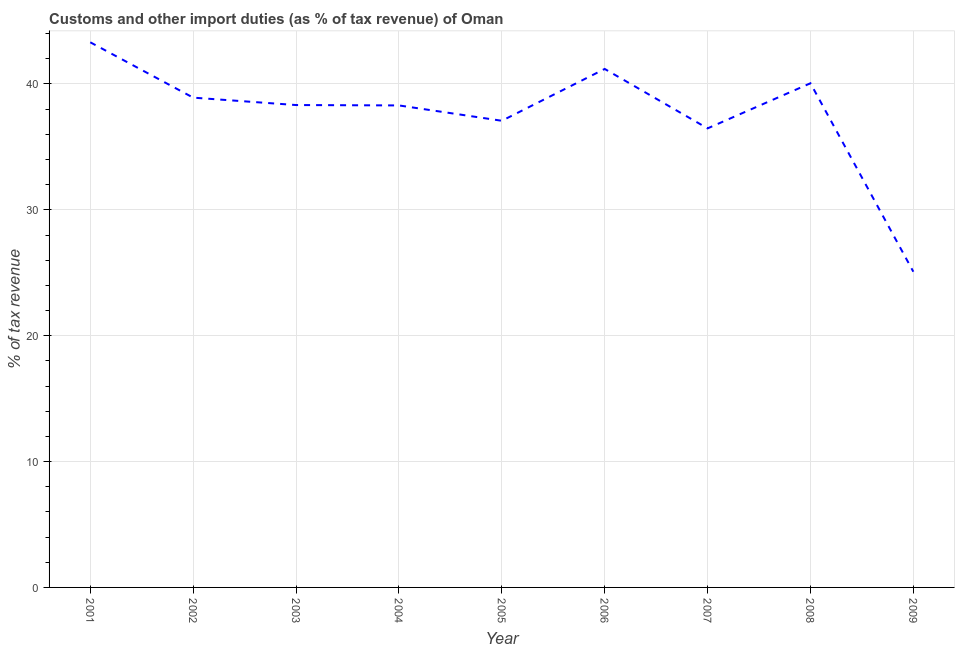What is the customs and other import duties in 2009?
Your response must be concise. 25.08. Across all years, what is the maximum customs and other import duties?
Provide a short and direct response. 43.31. Across all years, what is the minimum customs and other import duties?
Provide a short and direct response. 25.08. What is the sum of the customs and other import duties?
Keep it short and to the point. 338.73. What is the difference between the customs and other import duties in 2001 and 2003?
Provide a succinct answer. 4.99. What is the average customs and other import duties per year?
Your answer should be very brief. 37.64. What is the median customs and other import duties?
Provide a short and direct response. 38.33. In how many years, is the customs and other import duties greater than 34 %?
Offer a very short reply. 8. Do a majority of the years between 2009 and 2006 (inclusive) have customs and other import duties greater than 10 %?
Your answer should be compact. Yes. What is the ratio of the customs and other import duties in 2001 to that in 2002?
Your response must be concise. 1.11. Is the customs and other import duties in 2004 less than that in 2005?
Offer a terse response. No. Is the difference between the customs and other import duties in 2001 and 2002 greater than the difference between any two years?
Keep it short and to the point. No. What is the difference between the highest and the second highest customs and other import duties?
Your answer should be compact. 2.12. Is the sum of the customs and other import duties in 2007 and 2009 greater than the maximum customs and other import duties across all years?
Your answer should be compact. Yes. What is the difference between the highest and the lowest customs and other import duties?
Ensure brevity in your answer.  18.23. Are the values on the major ticks of Y-axis written in scientific E-notation?
Provide a short and direct response. No. Does the graph contain any zero values?
Provide a succinct answer. No. Does the graph contain grids?
Provide a succinct answer. Yes. What is the title of the graph?
Offer a very short reply. Customs and other import duties (as % of tax revenue) of Oman. What is the label or title of the X-axis?
Your answer should be very brief. Year. What is the label or title of the Y-axis?
Provide a short and direct response. % of tax revenue. What is the % of tax revenue in 2001?
Offer a terse response. 43.31. What is the % of tax revenue in 2002?
Your answer should be compact. 38.91. What is the % of tax revenue in 2003?
Your response must be concise. 38.33. What is the % of tax revenue of 2004?
Make the answer very short. 38.3. What is the % of tax revenue in 2005?
Your response must be concise. 37.08. What is the % of tax revenue in 2006?
Give a very brief answer. 41.19. What is the % of tax revenue in 2007?
Your response must be concise. 36.47. What is the % of tax revenue of 2008?
Offer a very short reply. 40.06. What is the % of tax revenue of 2009?
Your answer should be compact. 25.08. What is the difference between the % of tax revenue in 2001 and 2002?
Ensure brevity in your answer.  4.4. What is the difference between the % of tax revenue in 2001 and 2003?
Ensure brevity in your answer.  4.99. What is the difference between the % of tax revenue in 2001 and 2004?
Ensure brevity in your answer.  5.02. What is the difference between the % of tax revenue in 2001 and 2005?
Your response must be concise. 6.24. What is the difference between the % of tax revenue in 2001 and 2006?
Give a very brief answer. 2.12. What is the difference between the % of tax revenue in 2001 and 2007?
Provide a short and direct response. 6.84. What is the difference between the % of tax revenue in 2001 and 2008?
Your response must be concise. 3.25. What is the difference between the % of tax revenue in 2001 and 2009?
Provide a short and direct response. 18.23. What is the difference between the % of tax revenue in 2002 and 2003?
Make the answer very short. 0.59. What is the difference between the % of tax revenue in 2002 and 2004?
Make the answer very short. 0.62. What is the difference between the % of tax revenue in 2002 and 2005?
Provide a short and direct response. 1.84. What is the difference between the % of tax revenue in 2002 and 2006?
Keep it short and to the point. -2.28. What is the difference between the % of tax revenue in 2002 and 2007?
Offer a terse response. 2.44. What is the difference between the % of tax revenue in 2002 and 2008?
Ensure brevity in your answer.  -1.14. What is the difference between the % of tax revenue in 2002 and 2009?
Ensure brevity in your answer.  13.83. What is the difference between the % of tax revenue in 2003 and 2004?
Keep it short and to the point. 0.03. What is the difference between the % of tax revenue in 2003 and 2005?
Provide a succinct answer. 1.25. What is the difference between the % of tax revenue in 2003 and 2006?
Give a very brief answer. -2.87. What is the difference between the % of tax revenue in 2003 and 2007?
Make the answer very short. 1.85. What is the difference between the % of tax revenue in 2003 and 2008?
Keep it short and to the point. -1.73. What is the difference between the % of tax revenue in 2003 and 2009?
Keep it short and to the point. 13.24. What is the difference between the % of tax revenue in 2004 and 2005?
Your response must be concise. 1.22. What is the difference between the % of tax revenue in 2004 and 2006?
Give a very brief answer. -2.9. What is the difference between the % of tax revenue in 2004 and 2007?
Make the answer very short. 1.82. What is the difference between the % of tax revenue in 2004 and 2008?
Your response must be concise. -1.76. What is the difference between the % of tax revenue in 2004 and 2009?
Your answer should be very brief. 13.21. What is the difference between the % of tax revenue in 2005 and 2006?
Your response must be concise. -4.12. What is the difference between the % of tax revenue in 2005 and 2007?
Keep it short and to the point. 0.6. What is the difference between the % of tax revenue in 2005 and 2008?
Your answer should be compact. -2.98. What is the difference between the % of tax revenue in 2005 and 2009?
Ensure brevity in your answer.  11.99. What is the difference between the % of tax revenue in 2006 and 2007?
Offer a very short reply. 4.72. What is the difference between the % of tax revenue in 2006 and 2008?
Your answer should be compact. 1.14. What is the difference between the % of tax revenue in 2006 and 2009?
Give a very brief answer. 16.11. What is the difference between the % of tax revenue in 2007 and 2008?
Make the answer very short. -3.58. What is the difference between the % of tax revenue in 2007 and 2009?
Offer a very short reply. 11.39. What is the difference between the % of tax revenue in 2008 and 2009?
Your answer should be compact. 14.97. What is the ratio of the % of tax revenue in 2001 to that in 2002?
Provide a succinct answer. 1.11. What is the ratio of the % of tax revenue in 2001 to that in 2003?
Offer a very short reply. 1.13. What is the ratio of the % of tax revenue in 2001 to that in 2004?
Provide a succinct answer. 1.13. What is the ratio of the % of tax revenue in 2001 to that in 2005?
Keep it short and to the point. 1.17. What is the ratio of the % of tax revenue in 2001 to that in 2006?
Give a very brief answer. 1.05. What is the ratio of the % of tax revenue in 2001 to that in 2007?
Your answer should be very brief. 1.19. What is the ratio of the % of tax revenue in 2001 to that in 2008?
Keep it short and to the point. 1.08. What is the ratio of the % of tax revenue in 2001 to that in 2009?
Keep it short and to the point. 1.73. What is the ratio of the % of tax revenue in 2002 to that in 2005?
Ensure brevity in your answer.  1.05. What is the ratio of the % of tax revenue in 2002 to that in 2006?
Give a very brief answer. 0.94. What is the ratio of the % of tax revenue in 2002 to that in 2007?
Keep it short and to the point. 1.07. What is the ratio of the % of tax revenue in 2002 to that in 2009?
Your response must be concise. 1.55. What is the ratio of the % of tax revenue in 2003 to that in 2004?
Your answer should be compact. 1. What is the ratio of the % of tax revenue in 2003 to that in 2005?
Offer a very short reply. 1.03. What is the ratio of the % of tax revenue in 2003 to that in 2007?
Keep it short and to the point. 1.05. What is the ratio of the % of tax revenue in 2003 to that in 2009?
Make the answer very short. 1.53. What is the ratio of the % of tax revenue in 2004 to that in 2005?
Give a very brief answer. 1.03. What is the ratio of the % of tax revenue in 2004 to that in 2006?
Offer a terse response. 0.93. What is the ratio of the % of tax revenue in 2004 to that in 2007?
Provide a succinct answer. 1.05. What is the ratio of the % of tax revenue in 2004 to that in 2008?
Give a very brief answer. 0.96. What is the ratio of the % of tax revenue in 2004 to that in 2009?
Keep it short and to the point. 1.53. What is the ratio of the % of tax revenue in 2005 to that in 2006?
Offer a very short reply. 0.9. What is the ratio of the % of tax revenue in 2005 to that in 2007?
Your response must be concise. 1.02. What is the ratio of the % of tax revenue in 2005 to that in 2008?
Offer a very short reply. 0.93. What is the ratio of the % of tax revenue in 2005 to that in 2009?
Your answer should be compact. 1.48. What is the ratio of the % of tax revenue in 2006 to that in 2007?
Offer a very short reply. 1.13. What is the ratio of the % of tax revenue in 2006 to that in 2008?
Offer a very short reply. 1.03. What is the ratio of the % of tax revenue in 2006 to that in 2009?
Give a very brief answer. 1.64. What is the ratio of the % of tax revenue in 2007 to that in 2008?
Keep it short and to the point. 0.91. What is the ratio of the % of tax revenue in 2007 to that in 2009?
Keep it short and to the point. 1.45. What is the ratio of the % of tax revenue in 2008 to that in 2009?
Make the answer very short. 1.6. 